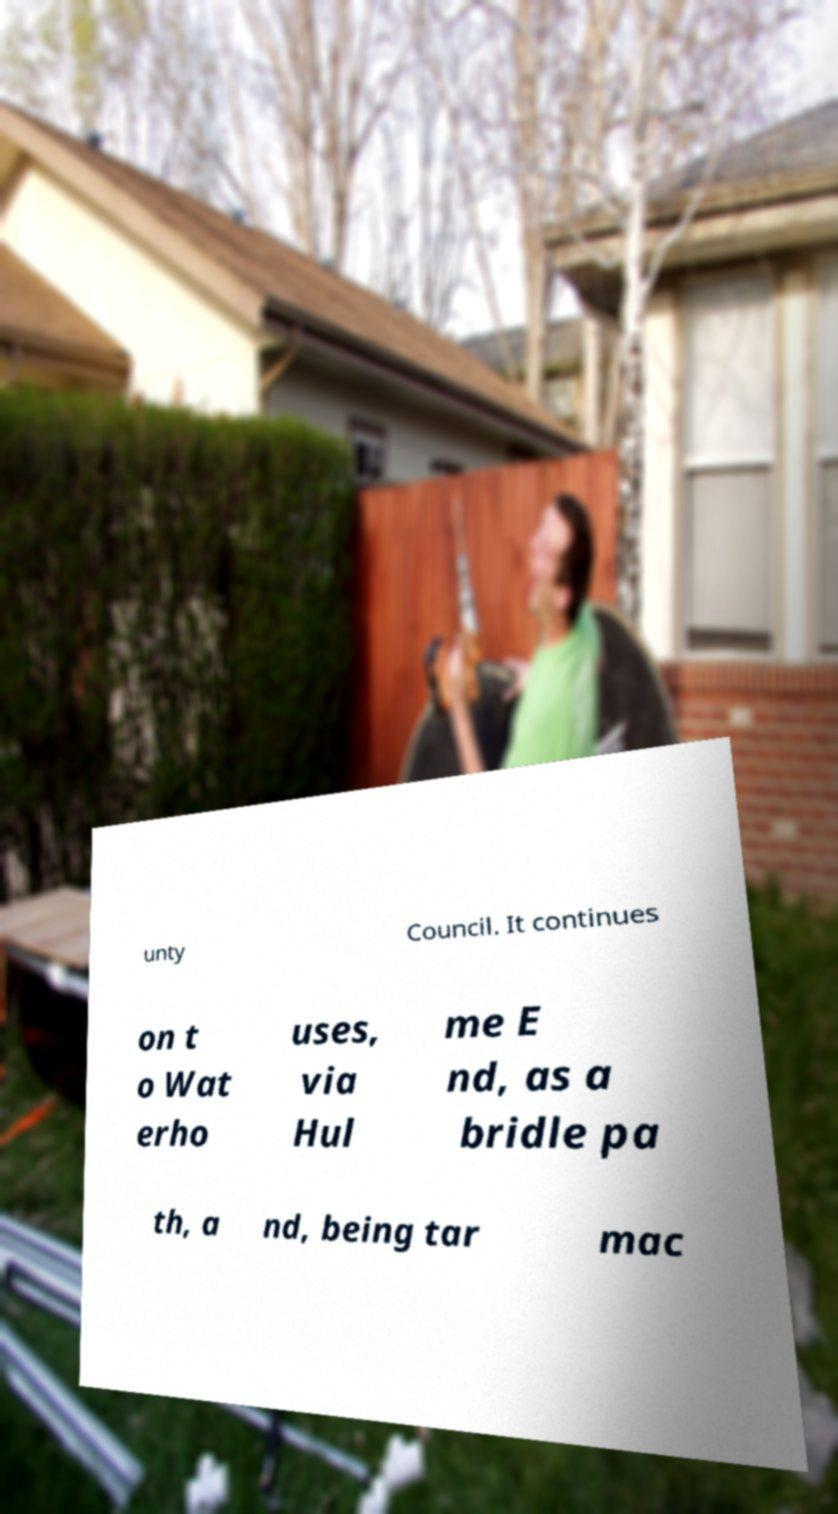I need the written content from this picture converted into text. Can you do that? unty Council. It continues on t o Wat erho uses, via Hul me E nd, as a bridle pa th, a nd, being tar mac 